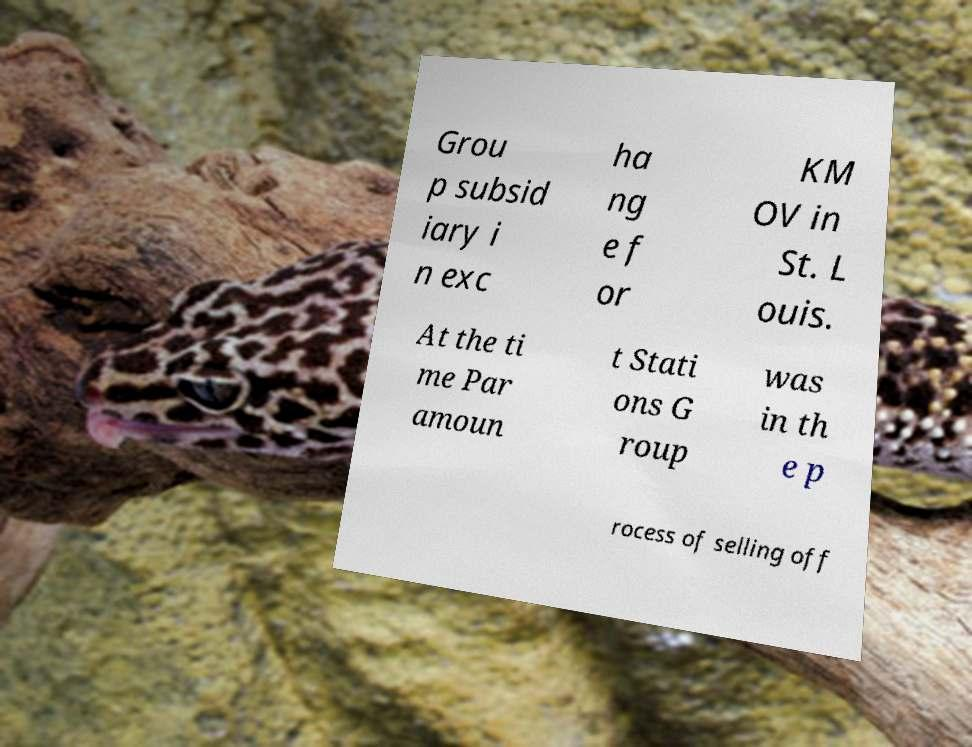What messages or text are displayed in this image? I need them in a readable, typed format. Grou p subsid iary i n exc ha ng e f or KM OV in St. L ouis. At the ti me Par amoun t Stati ons G roup was in th e p rocess of selling off 